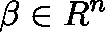Convert formula to latex. <formula><loc_0><loc_0><loc_500><loc_500>\beta \in \mathbb { R } ^ { n }</formula> 